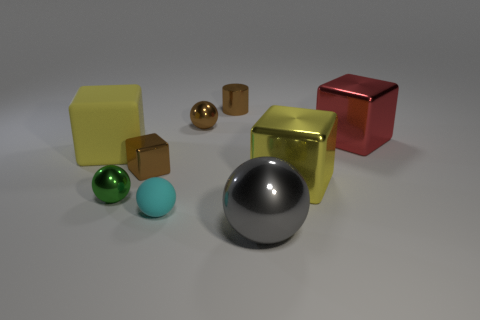What size is the block that is both right of the yellow matte block and to the left of the brown shiny sphere?
Offer a terse response. Small. There is a big yellow matte thing that is left of the metallic ball that is in front of the small green metal thing; what number of shiny blocks are in front of it?
Offer a very short reply. 2. Is there a large rubber thing of the same color as the tiny cube?
Your answer should be compact. No. What is the color of the cylinder that is the same size as the green metallic ball?
Your answer should be very brief. Brown. There is a big yellow thing to the right of the yellow block that is on the left side of the large yellow object to the right of the big ball; what is its shape?
Your response must be concise. Cube. There is a small metal ball in front of the large red object; how many yellow shiny cubes are in front of it?
Ensure brevity in your answer.  0. There is a big yellow thing on the left side of the small cyan object; is its shape the same as the big yellow object that is on the right side of the gray ball?
Ensure brevity in your answer.  Yes. There is a gray object; what number of tiny green things are in front of it?
Your answer should be very brief. 0. Are the yellow block left of the big gray shiny object and the green object made of the same material?
Your response must be concise. No. There is another tiny metallic thing that is the same shape as the small green thing; what is its color?
Offer a very short reply. Brown. 